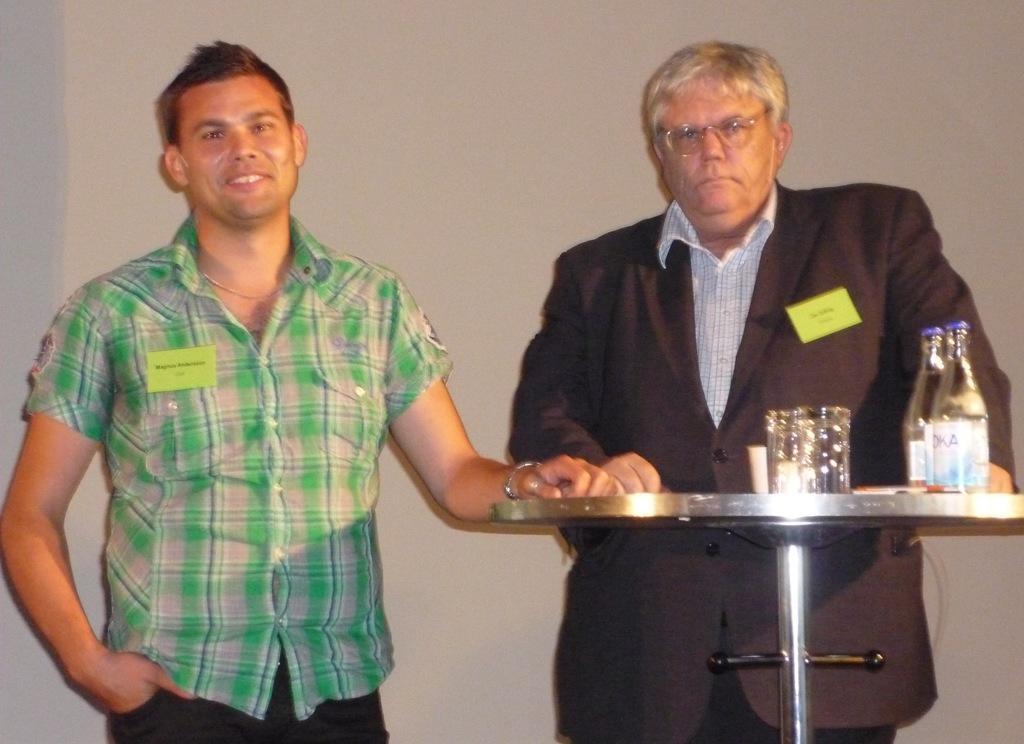How would you summarize this image in a sentence or two? In this image there are two men standing. At the right side man wearing black colour suit is standing in front of the table. At the left side the man wearing green colour shirt is standing and having smile on his face. In the front there is a table, on the table there are two bottles, glasses. In the background there is a wall. 